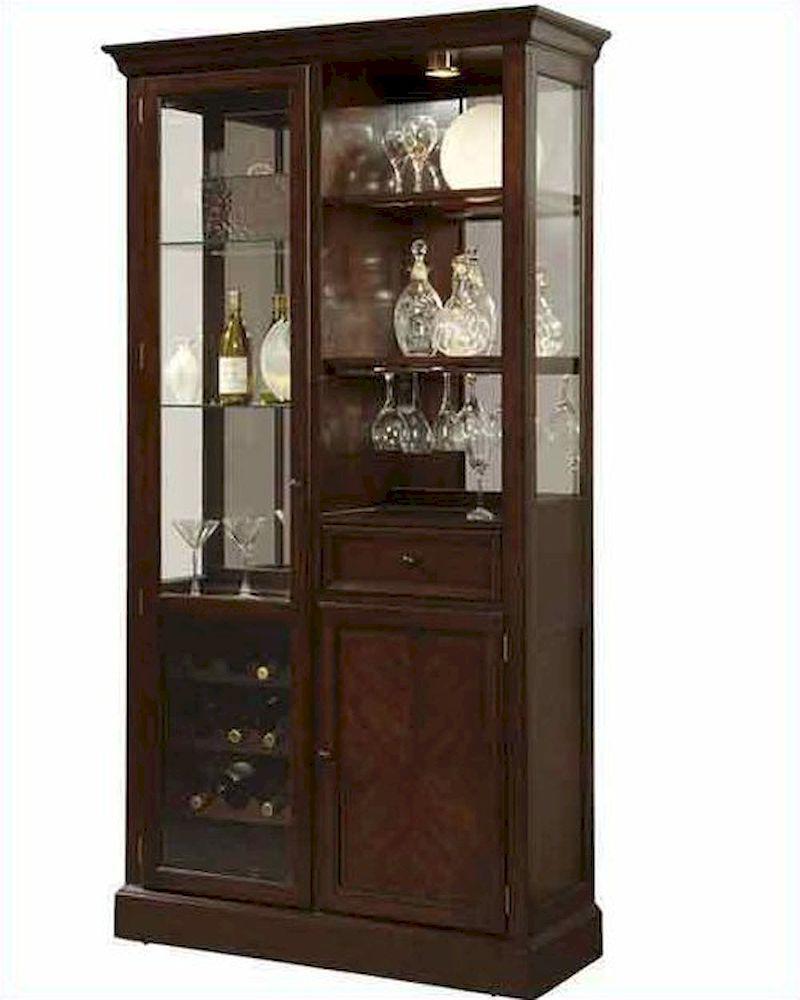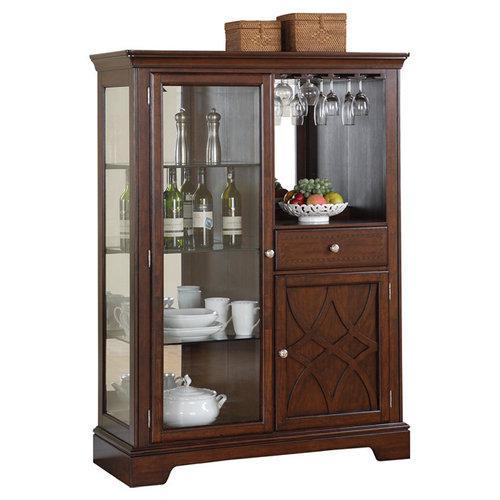The first image is the image on the left, the second image is the image on the right. For the images shown, is this caption "A wooden hutch in one image has a middle open section with three glass doors above, and a section with drawers and solid panel doors below." true? Answer yes or no. No. The first image is the image on the left, the second image is the image on the right. Assess this claim about the two images: "One of the cabinets has an arched, curved top, and both cabinets have some type of feet.". Correct or not? Answer yes or no. No. 